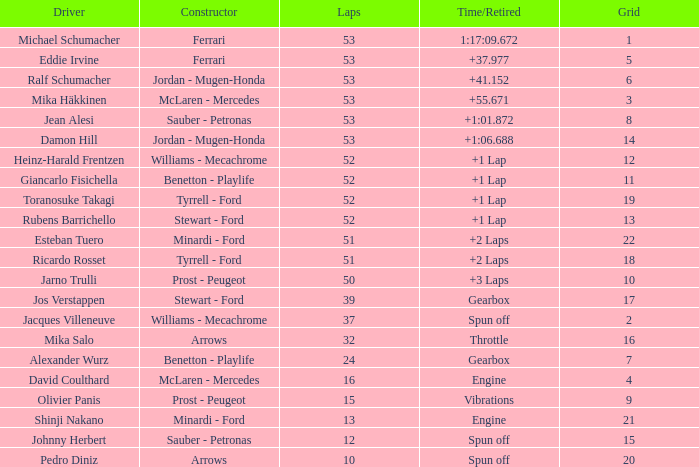What is the grid sum for ralf schumacher competing in 53 laps? None. 